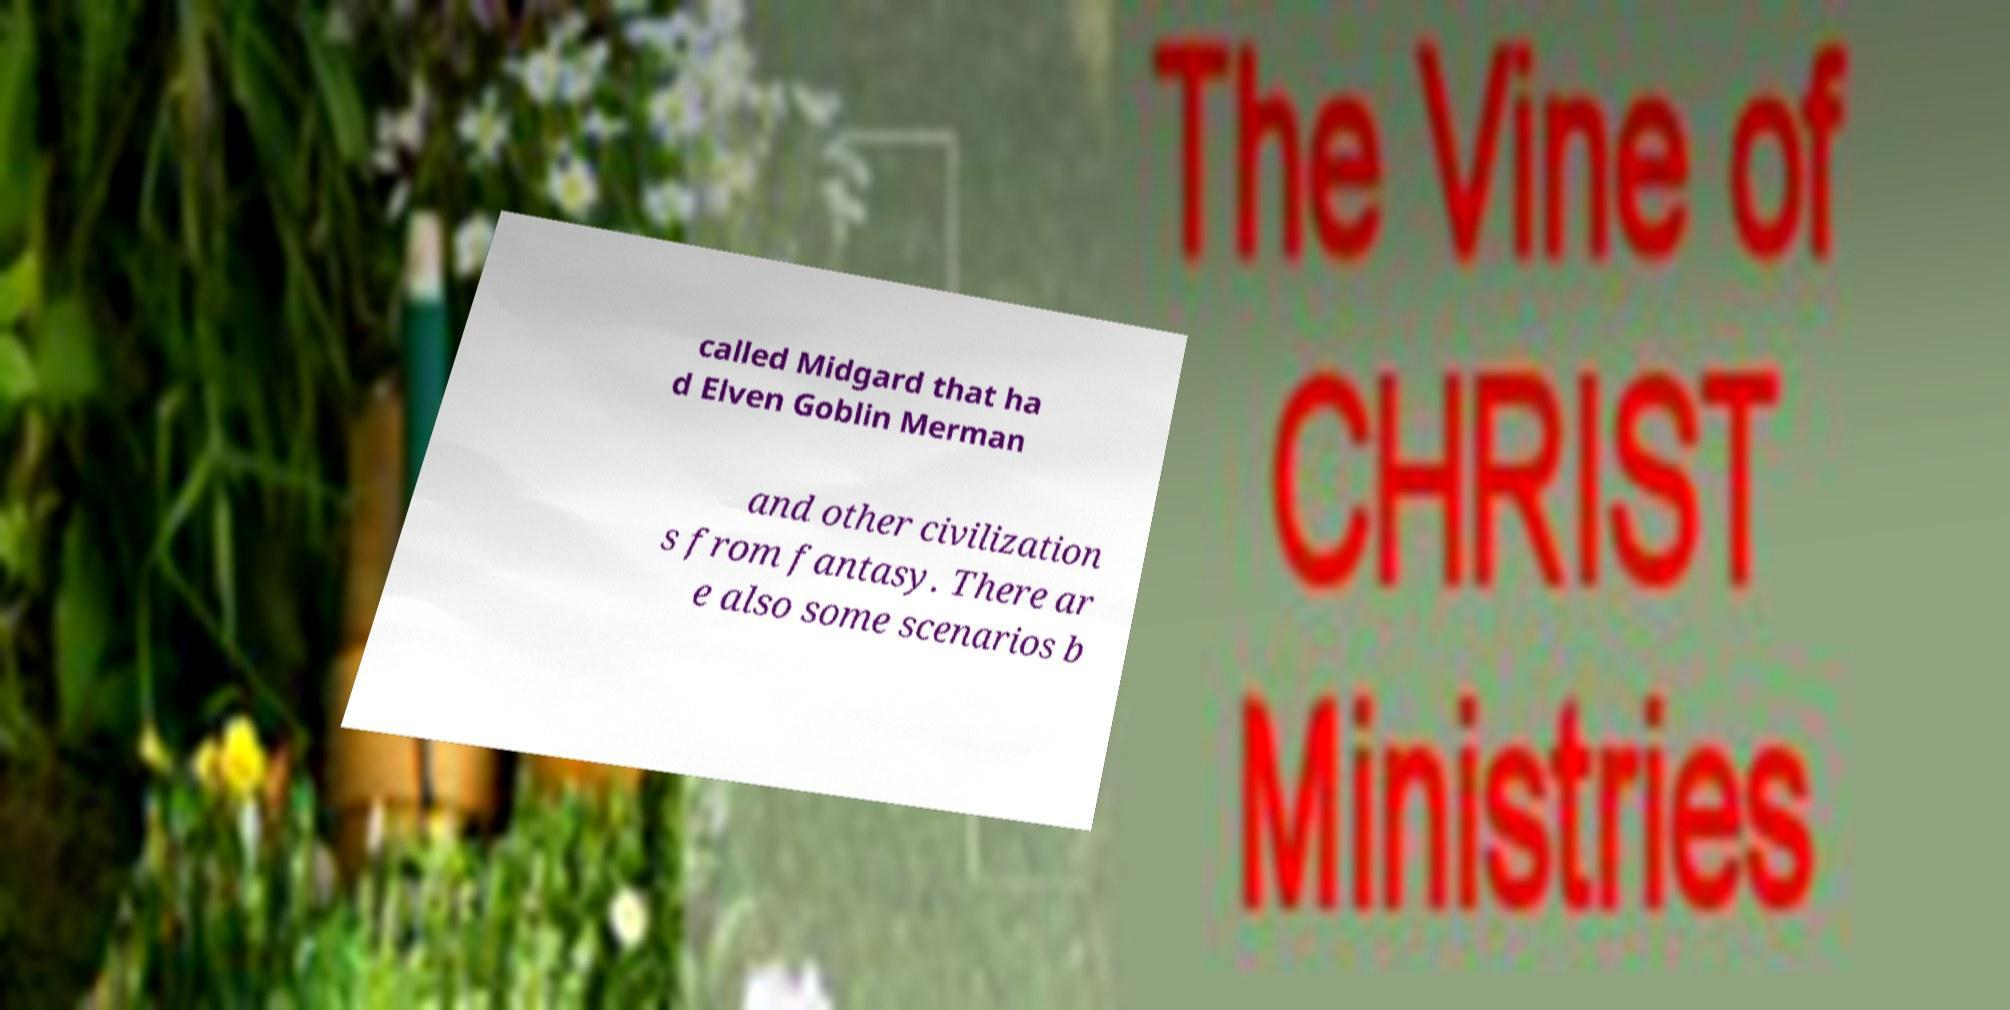Can you read and provide the text displayed in the image?This photo seems to have some interesting text. Can you extract and type it out for me? called Midgard that ha d Elven Goblin Merman and other civilization s from fantasy. There ar e also some scenarios b 